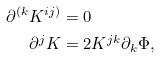Convert formula to latex. <formula><loc_0><loc_0><loc_500><loc_500>\partial ^ { ( k } K ^ { i j ) } & = 0 \\ \partial ^ { j } K & = 2 K ^ { j k } \partial _ { k } \Phi ,</formula> 